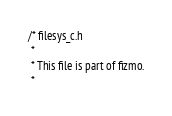<code> <loc_0><loc_0><loc_500><loc_500><_C_>
/* filesys_c.h
 *
 * This file is part of fizmo.
 *</code> 